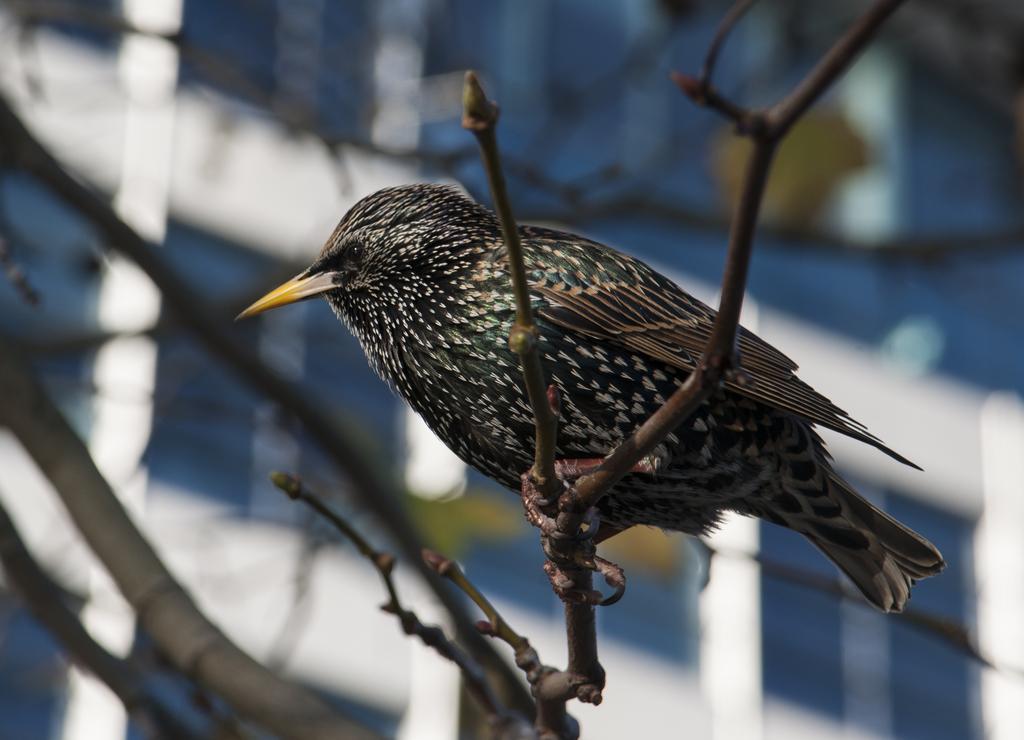Describe this image in one or two sentences. In this picture I can see few stems in front and in the center of this picture I can see a bird which is of white, black, brown and yellow color. I see that it is blurred in the background and I can see a building. 